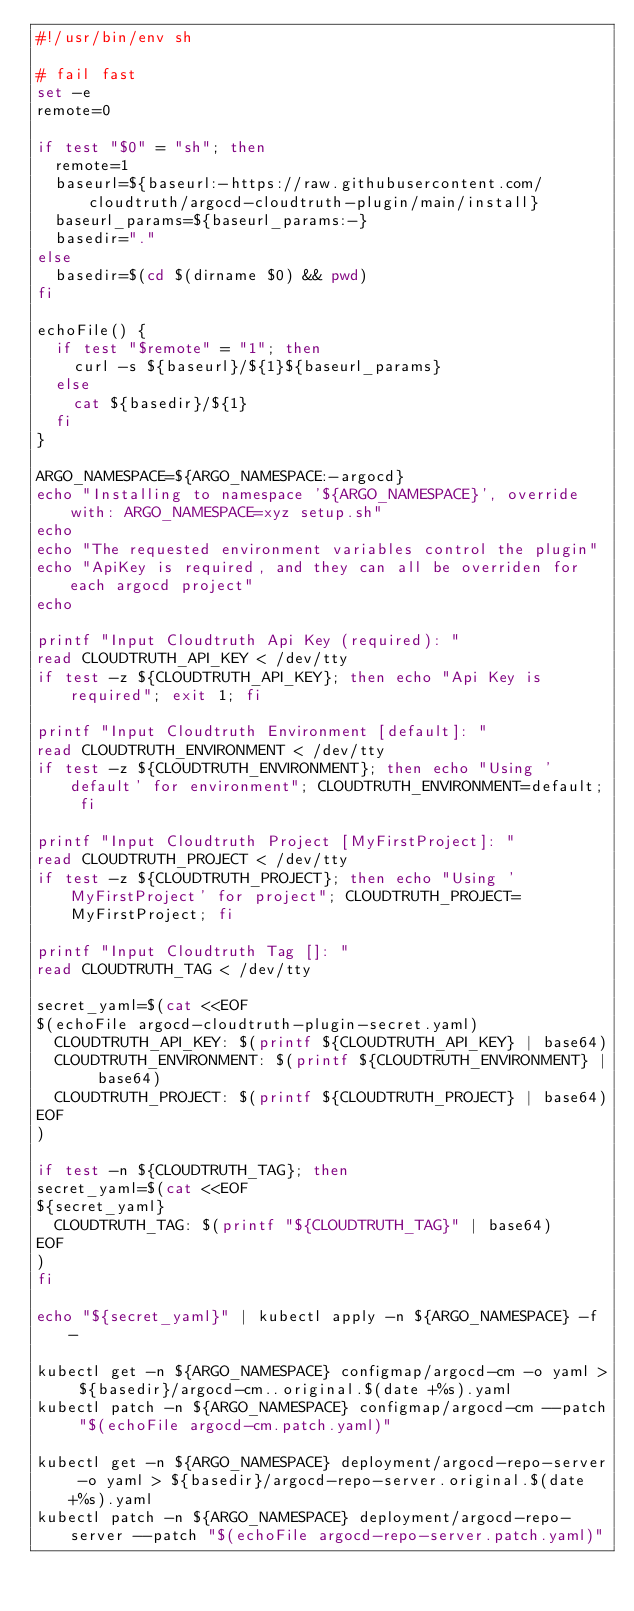<code> <loc_0><loc_0><loc_500><loc_500><_Bash_>#!/usr/bin/env sh

# fail fast
set -e
remote=0

if test "$0" = "sh"; then
  remote=1
  baseurl=${baseurl:-https://raw.githubusercontent.com/cloudtruth/argocd-cloudtruth-plugin/main/install}
  baseurl_params=${baseurl_params:-}
  basedir="."
else
  basedir=$(cd $(dirname $0) && pwd)
fi

echoFile() {
  if test "$remote" = "1"; then
    curl -s ${baseurl}/${1}${baseurl_params}
  else
    cat ${basedir}/${1}
  fi
}

ARGO_NAMESPACE=${ARGO_NAMESPACE:-argocd}
echo "Installing to namespace '${ARGO_NAMESPACE}', override with: ARGO_NAMESPACE=xyz setup.sh"
echo
echo "The requested environment variables control the plugin"
echo "ApiKey is required, and they can all be overriden for each argocd project"
echo

printf "Input Cloudtruth Api Key (required): "
read CLOUDTRUTH_API_KEY < /dev/tty
if test -z ${CLOUDTRUTH_API_KEY}; then echo "Api Key is required"; exit 1; fi

printf "Input Cloudtruth Environment [default]: "
read CLOUDTRUTH_ENVIRONMENT < /dev/tty
if test -z ${CLOUDTRUTH_ENVIRONMENT}; then echo "Using 'default' for environment"; CLOUDTRUTH_ENVIRONMENT=default; fi

printf "Input Cloudtruth Project [MyFirstProject]: "
read CLOUDTRUTH_PROJECT < /dev/tty
if test -z ${CLOUDTRUTH_PROJECT}; then echo "Using 'MyFirstProject' for project"; CLOUDTRUTH_PROJECT=MyFirstProject; fi

printf "Input Cloudtruth Tag []: "
read CLOUDTRUTH_TAG < /dev/tty

secret_yaml=$(cat <<EOF
$(echoFile argocd-cloudtruth-plugin-secret.yaml)
  CLOUDTRUTH_API_KEY: $(printf ${CLOUDTRUTH_API_KEY} | base64)
  CLOUDTRUTH_ENVIRONMENT: $(printf ${CLOUDTRUTH_ENVIRONMENT} | base64)
  CLOUDTRUTH_PROJECT: $(printf ${CLOUDTRUTH_PROJECT} | base64)
EOF
)

if test -n ${CLOUDTRUTH_TAG}; then
secret_yaml=$(cat <<EOF
${secret_yaml}
  CLOUDTRUTH_TAG: $(printf "${CLOUDTRUTH_TAG}" | base64)
EOF
)
fi

echo "${secret_yaml}" | kubectl apply -n ${ARGO_NAMESPACE} -f -

kubectl get -n ${ARGO_NAMESPACE} configmap/argocd-cm -o yaml > ${basedir}/argocd-cm..original.$(date +%s).yaml
kubectl patch -n ${ARGO_NAMESPACE} configmap/argocd-cm --patch "$(echoFile argocd-cm.patch.yaml)"

kubectl get -n ${ARGO_NAMESPACE} deployment/argocd-repo-server -o yaml > ${basedir}/argocd-repo-server.original.$(date +%s).yaml
kubectl patch -n ${ARGO_NAMESPACE} deployment/argocd-repo-server --patch "$(echoFile argocd-repo-server.patch.yaml)"
</code> 